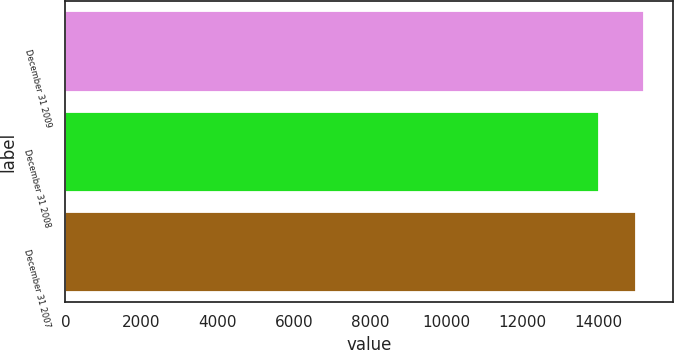<chart> <loc_0><loc_0><loc_500><loc_500><bar_chart><fcel>December 31 2009<fcel>December 31 2008<fcel>December 31 2007<nl><fcel>15207<fcel>14019<fcel>15006<nl></chart> 